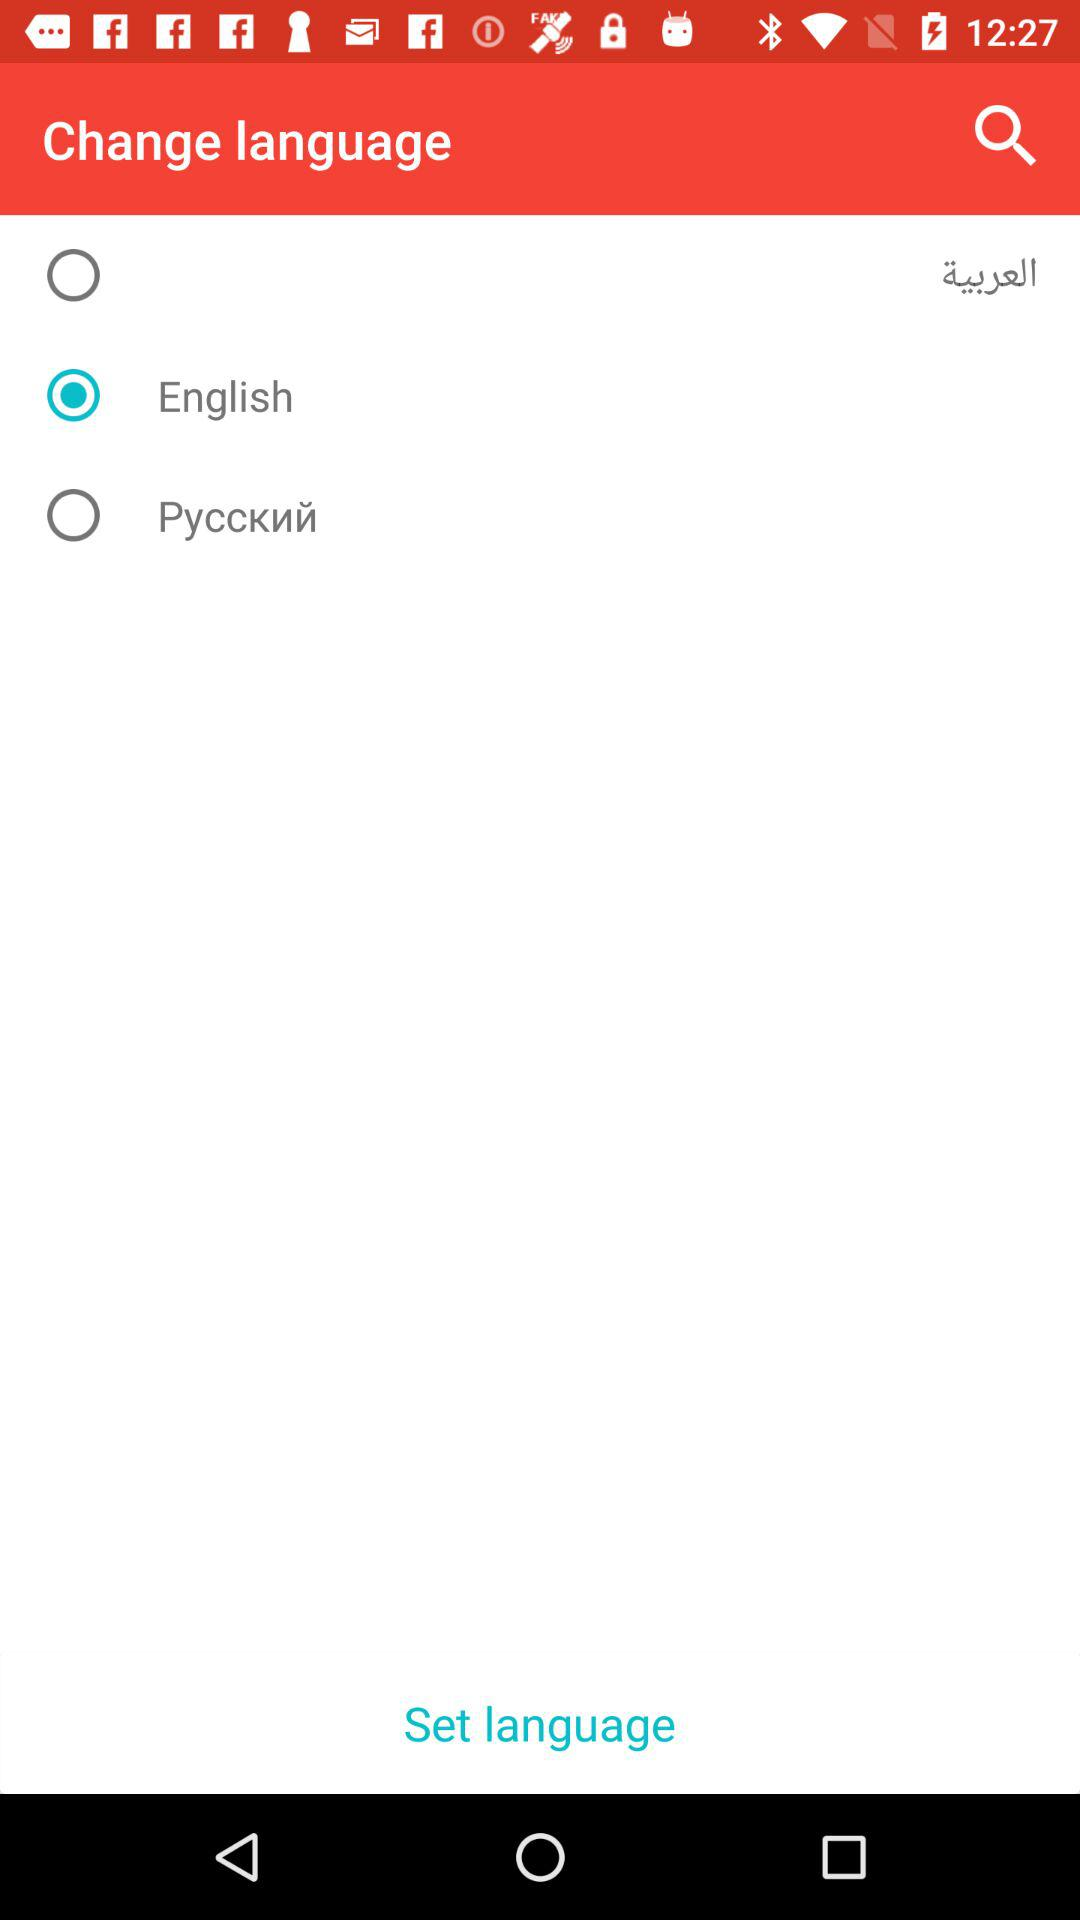Which language is selected? The selected language is English. 